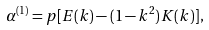<formula> <loc_0><loc_0><loc_500><loc_500>\alpha ^ { ( 1 ) } = p [ E ( k ) - ( 1 - k ^ { 2 } ) K ( k ) ] ,</formula> 